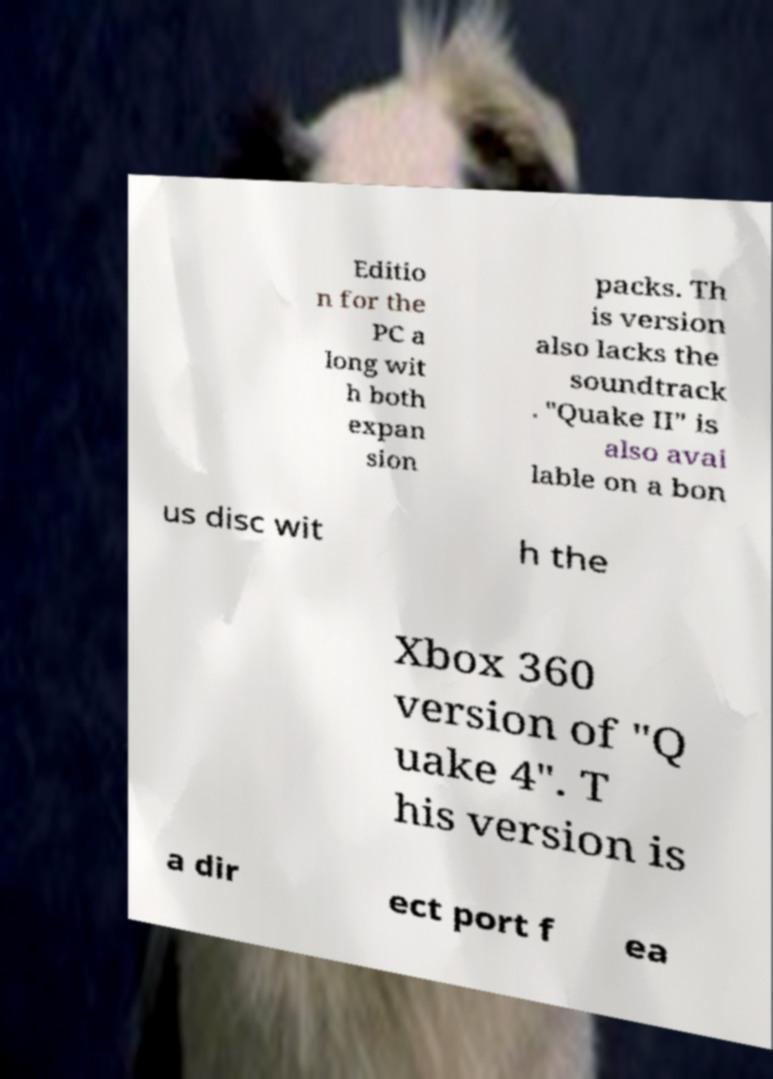Please read and relay the text visible in this image. What does it say? Editio n for the PC a long wit h both expan sion packs. Th is version also lacks the soundtrack . "Quake II" is also avai lable on a bon us disc wit h the Xbox 360 version of "Q uake 4". T his version is a dir ect port f ea 